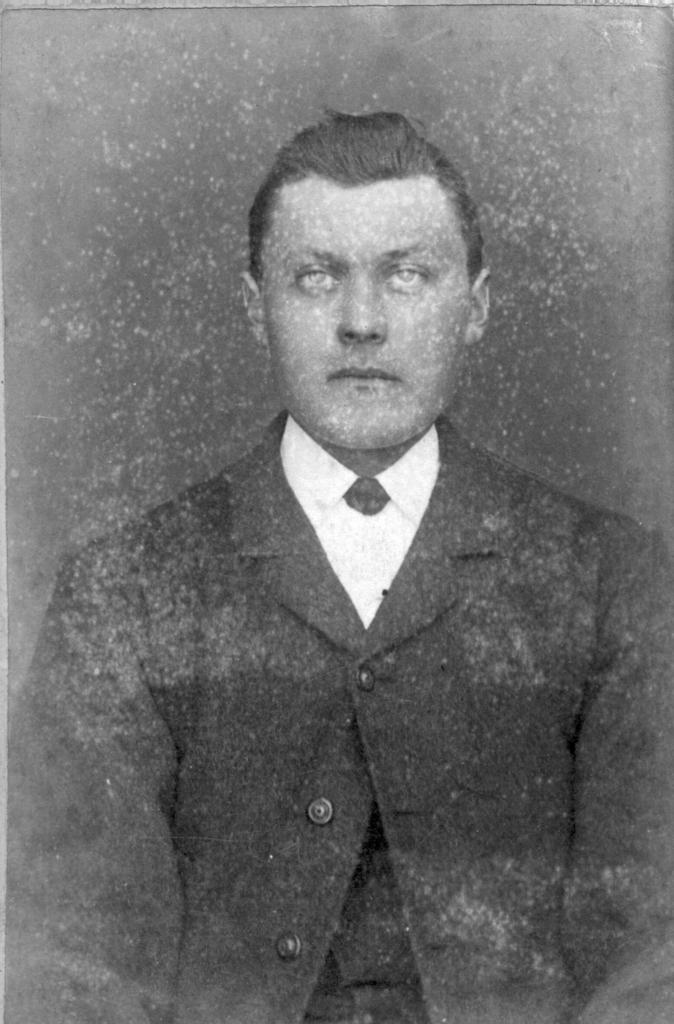What is the main subject of the image? There is a photo of a person in the image. What type of horse is depicted in the image? There is no horse present in the image; it features a photo of a person. Is the person in the image a crook? The image does not provide any information about the person's character or actions, so it cannot be determined if they are a crook. 